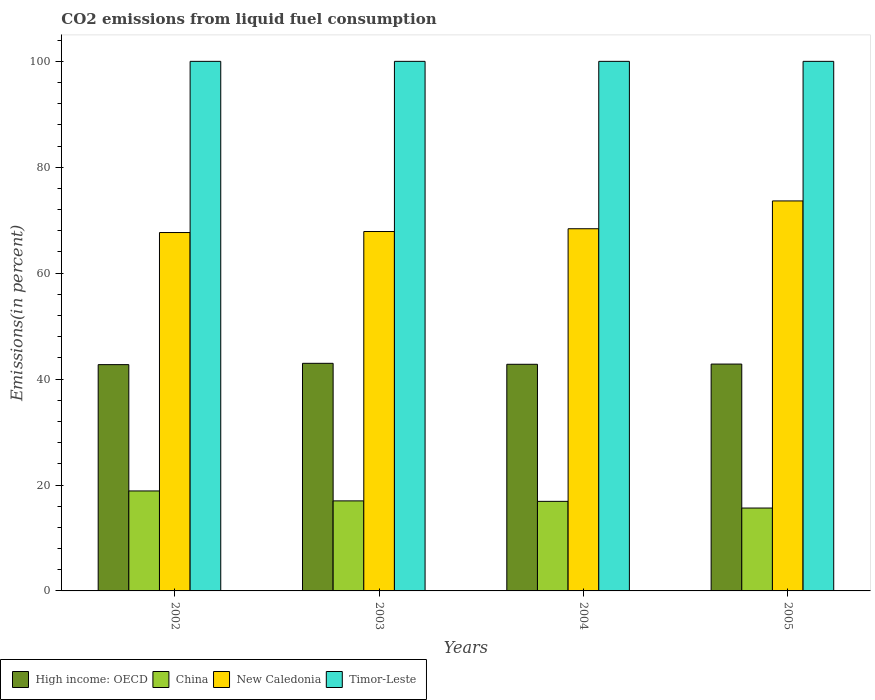How many different coloured bars are there?
Your response must be concise. 4. Are the number of bars on each tick of the X-axis equal?
Your answer should be compact. Yes. What is the label of the 1st group of bars from the left?
Ensure brevity in your answer.  2002. In how many cases, is the number of bars for a given year not equal to the number of legend labels?
Give a very brief answer. 0. What is the total CO2 emitted in New Caledonia in 2002?
Offer a terse response. 67.67. Across all years, what is the maximum total CO2 emitted in Timor-Leste?
Ensure brevity in your answer.  100. Across all years, what is the minimum total CO2 emitted in High income: OECD?
Your response must be concise. 42.73. In which year was the total CO2 emitted in New Caledonia maximum?
Offer a very short reply. 2005. In which year was the total CO2 emitted in China minimum?
Ensure brevity in your answer.  2005. What is the total total CO2 emitted in New Caledonia in the graph?
Offer a terse response. 277.57. What is the difference between the total CO2 emitted in New Caledonia in 2004 and that in 2005?
Your response must be concise. -5.25. What is the difference between the total CO2 emitted in China in 2003 and the total CO2 emitted in Timor-Leste in 2005?
Your response must be concise. -83. What is the average total CO2 emitted in China per year?
Your answer should be compact. 17.11. In the year 2002, what is the difference between the total CO2 emitted in High income: OECD and total CO2 emitted in New Caledonia?
Keep it short and to the point. -24.94. What is the ratio of the total CO2 emitted in China in 2002 to that in 2005?
Ensure brevity in your answer.  1.21. Is the total CO2 emitted in High income: OECD in 2004 less than that in 2005?
Provide a succinct answer. Yes. Is the difference between the total CO2 emitted in High income: OECD in 2002 and 2003 greater than the difference between the total CO2 emitted in New Caledonia in 2002 and 2003?
Your answer should be compact. No. What is the difference between the highest and the second highest total CO2 emitted in China?
Your answer should be very brief. 1.88. Is the sum of the total CO2 emitted in High income: OECD in 2002 and 2003 greater than the maximum total CO2 emitted in New Caledonia across all years?
Provide a succinct answer. Yes. Is it the case that in every year, the sum of the total CO2 emitted in New Caledonia and total CO2 emitted in High income: OECD is greater than the sum of total CO2 emitted in China and total CO2 emitted in Timor-Leste?
Your answer should be compact. No. What does the 1st bar from the left in 2002 represents?
Your response must be concise. High income: OECD. Are all the bars in the graph horizontal?
Offer a very short reply. No. What is the difference between two consecutive major ticks on the Y-axis?
Your answer should be very brief. 20. Are the values on the major ticks of Y-axis written in scientific E-notation?
Your response must be concise. No. Does the graph contain any zero values?
Your answer should be very brief. No. How many legend labels are there?
Offer a very short reply. 4. How are the legend labels stacked?
Offer a terse response. Horizontal. What is the title of the graph?
Your answer should be compact. CO2 emissions from liquid fuel consumption. Does "Iraq" appear as one of the legend labels in the graph?
Offer a very short reply. No. What is the label or title of the X-axis?
Your answer should be very brief. Years. What is the label or title of the Y-axis?
Give a very brief answer. Emissions(in percent). What is the Emissions(in percent) in High income: OECD in 2002?
Your response must be concise. 42.73. What is the Emissions(in percent) of China in 2002?
Provide a succinct answer. 18.88. What is the Emissions(in percent) in New Caledonia in 2002?
Offer a very short reply. 67.67. What is the Emissions(in percent) of High income: OECD in 2003?
Offer a terse response. 42.98. What is the Emissions(in percent) in China in 2003?
Make the answer very short. 17. What is the Emissions(in percent) in New Caledonia in 2003?
Ensure brevity in your answer.  67.87. What is the Emissions(in percent) in Timor-Leste in 2003?
Ensure brevity in your answer.  100. What is the Emissions(in percent) of High income: OECD in 2004?
Your answer should be very brief. 42.8. What is the Emissions(in percent) in China in 2004?
Offer a very short reply. 16.91. What is the Emissions(in percent) of New Caledonia in 2004?
Offer a terse response. 68.39. What is the Emissions(in percent) in High income: OECD in 2005?
Your answer should be compact. 42.84. What is the Emissions(in percent) in China in 2005?
Offer a terse response. 15.65. What is the Emissions(in percent) in New Caledonia in 2005?
Give a very brief answer. 73.64. What is the Emissions(in percent) in Timor-Leste in 2005?
Offer a very short reply. 100. Across all years, what is the maximum Emissions(in percent) in High income: OECD?
Your answer should be compact. 42.98. Across all years, what is the maximum Emissions(in percent) in China?
Your response must be concise. 18.88. Across all years, what is the maximum Emissions(in percent) of New Caledonia?
Make the answer very short. 73.64. Across all years, what is the maximum Emissions(in percent) of Timor-Leste?
Provide a short and direct response. 100. Across all years, what is the minimum Emissions(in percent) of High income: OECD?
Give a very brief answer. 42.73. Across all years, what is the minimum Emissions(in percent) of China?
Offer a very short reply. 15.65. Across all years, what is the minimum Emissions(in percent) in New Caledonia?
Your answer should be very brief. 67.67. What is the total Emissions(in percent) in High income: OECD in the graph?
Your answer should be compact. 171.34. What is the total Emissions(in percent) of China in the graph?
Offer a very short reply. 68.44. What is the total Emissions(in percent) in New Caledonia in the graph?
Provide a short and direct response. 277.57. What is the difference between the Emissions(in percent) of High income: OECD in 2002 and that in 2003?
Offer a terse response. -0.25. What is the difference between the Emissions(in percent) of China in 2002 and that in 2003?
Your answer should be compact. 1.88. What is the difference between the Emissions(in percent) in New Caledonia in 2002 and that in 2003?
Your response must be concise. -0.19. What is the difference between the Emissions(in percent) of High income: OECD in 2002 and that in 2004?
Offer a very short reply. -0.07. What is the difference between the Emissions(in percent) of China in 2002 and that in 2004?
Ensure brevity in your answer.  1.96. What is the difference between the Emissions(in percent) of New Caledonia in 2002 and that in 2004?
Offer a terse response. -0.72. What is the difference between the Emissions(in percent) of Timor-Leste in 2002 and that in 2004?
Your response must be concise. 0. What is the difference between the Emissions(in percent) in High income: OECD in 2002 and that in 2005?
Ensure brevity in your answer.  -0.11. What is the difference between the Emissions(in percent) in China in 2002 and that in 2005?
Ensure brevity in your answer.  3.23. What is the difference between the Emissions(in percent) of New Caledonia in 2002 and that in 2005?
Your answer should be very brief. -5.97. What is the difference between the Emissions(in percent) in High income: OECD in 2003 and that in 2004?
Offer a terse response. 0.18. What is the difference between the Emissions(in percent) in China in 2003 and that in 2004?
Provide a succinct answer. 0.09. What is the difference between the Emissions(in percent) in New Caledonia in 2003 and that in 2004?
Give a very brief answer. -0.52. What is the difference between the Emissions(in percent) of Timor-Leste in 2003 and that in 2004?
Provide a short and direct response. 0. What is the difference between the Emissions(in percent) in High income: OECD in 2003 and that in 2005?
Ensure brevity in your answer.  0.14. What is the difference between the Emissions(in percent) of China in 2003 and that in 2005?
Your answer should be compact. 1.35. What is the difference between the Emissions(in percent) in New Caledonia in 2003 and that in 2005?
Give a very brief answer. -5.78. What is the difference between the Emissions(in percent) in Timor-Leste in 2003 and that in 2005?
Provide a short and direct response. 0. What is the difference between the Emissions(in percent) in High income: OECD in 2004 and that in 2005?
Offer a very short reply. -0.04. What is the difference between the Emissions(in percent) in China in 2004 and that in 2005?
Provide a short and direct response. 1.26. What is the difference between the Emissions(in percent) of New Caledonia in 2004 and that in 2005?
Provide a short and direct response. -5.25. What is the difference between the Emissions(in percent) of Timor-Leste in 2004 and that in 2005?
Give a very brief answer. 0. What is the difference between the Emissions(in percent) of High income: OECD in 2002 and the Emissions(in percent) of China in 2003?
Give a very brief answer. 25.73. What is the difference between the Emissions(in percent) of High income: OECD in 2002 and the Emissions(in percent) of New Caledonia in 2003?
Keep it short and to the point. -25.14. What is the difference between the Emissions(in percent) of High income: OECD in 2002 and the Emissions(in percent) of Timor-Leste in 2003?
Your answer should be compact. -57.27. What is the difference between the Emissions(in percent) of China in 2002 and the Emissions(in percent) of New Caledonia in 2003?
Keep it short and to the point. -48.99. What is the difference between the Emissions(in percent) of China in 2002 and the Emissions(in percent) of Timor-Leste in 2003?
Give a very brief answer. -81.12. What is the difference between the Emissions(in percent) in New Caledonia in 2002 and the Emissions(in percent) in Timor-Leste in 2003?
Ensure brevity in your answer.  -32.33. What is the difference between the Emissions(in percent) of High income: OECD in 2002 and the Emissions(in percent) of China in 2004?
Your answer should be compact. 25.82. What is the difference between the Emissions(in percent) of High income: OECD in 2002 and the Emissions(in percent) of New Caledonia in 2004?
Offer a very short reply. -25.66. What is the difference between the Emissions(in percent) of High income: OECD in 2002 and the Emissions(in percent) of Timor-Leste in 2004?
Your answer should be very brief. -57.27. What is the difference between the Emissions(in percent) of China in 2002 and the Emissions(in percent) of New Caledonia in 2004?
Your answer should be very brief. -49.51. What is the difference between the Emissions(in percent) in China in 2002 and the Emissions(in percent) in Timor-Leste in 2004?
Make the answer very short. -81.12. What is the difference between the Emissions(in percent) in New Caledonia in 2002 and the Emissions(in percent) in Timor-Leste in 2004?
Ensure brevity in your answer.  -32.33. What is the difference between the Emissions(in percent) in High income: OECD in 2002 and the Emissions(in percent) in China in 2005?
Your answer should be compact. 27.08. What is the difference between the Emissions(in percent) in High income: OECD in 2002 and the Emissions(in percent) in New Caledonia in 2005?
Your response must be concise. -30.91. What is the difference between the Emissions(in percent) of High income: OECD in 2002 and the Emissions(in percent) of Timor-Leste in 2005?
Your answer should be compact. -57.27. What is the difference between the Emissions(in percent) of China in 2002 and the Emissions(in percent) of New Caledonia in 2005?
Provide a short and direct response. -54.77. What is the difference between the Emissions(in percent) in China in 2002 and the Emissions(in percent) in Timor-Leste in 2005?
Your answer should be compact. -81.12. What is the difference between the Emissions(in percent) in New Caledonia in 2002 and the Emissions(in percent) in Timor-Leste in 2005?
Make the answer very short. -32.33. What is the difference between the Emissions(in percent) of High income: OECD in 2003 and the Emissions(in percent) of China in 2004?
Make the answer very short. 26.07. What is the difference between the Emissions(in percent) in High income: OECD in 2003 and the Emissions(in percent) in New Caledonia in 2004?
Offer a very short reply. -25.41. What is the difference between the Emissions(in percent) in High income: OECD in 2003 and the Emissions(in percent) in Timor-Leste in 2004?
Your answer should be compact. -57.02. What is the difference between the Emissions(in percent) of China in 2003 and the Emissions(in percent) of New Caledonia in 2004?
Offer a terse response. -51.39. What is the difference between the Emissions(in percent) of China in 2003 and the Emissions(in percent) of Timor-Leste in 2004?
Make the answer very short. -83. What is the difference between the Emissions(in percent) of New Caledonia in 2003 and the Emissions(in percent) of Timor-Leste in 2004?
Provide a succinct answer. -32.13. What is the difference between the Emissions(in percent) in High income: OECD in 2003 and the Emissions(in percent) in China in 2005?
Your answer should be very brief. 27.33. What is the difference between the Emissions(in percent) in High income: OECD in 2003 and the Emissions(in percent) in New Caledonia in 2005?
Your answer should be compact. -30.66. What is the difference between the Emissions(in percent) of High income: OECD in 2003 and the Emissions(in percent) of Timor-Leste in 2005?
Provide a short and direct response. -57.02. What is the difference between the Emissions(in percent) in China in 2003 and the Emissions(in percent) in New Caledonia in 2005?
Give a very brief answer. -56.64. What is the difference between the Emissions(in percent) in China in 2003 and the Emissions(in percent) in Timor-Leste in 2005?
Your answer should be very brief. -83. What is the difference between the Emissions(in percent) of New Caledonia in 2003 and the Emissions(in percent) of Timor-Leste in 2005?
Give a very brief answer. -32.13. What is the difference between the Emissions(in percent) of High income: OECD in 2004 and the Emissions(in percent) of China in 2005?
Make the answer very short. 27.15. What is the difference between the Emissions(in percent) in High income: OECD in 2004 and the Emissions(in percent) in New Caledonia in 2005?
Your response must be concise. -30.85. What is the difference between the Emissions(in percent) in High income: OECD in 2004 and the Emissions(in percent) in Timor-Leste in 2005?
Ensure brevity in your answer.  -57.2. What is the difference between the Emissions(in percent) in China in 2004 and the Emissions(in percent) in New Caledonia in 2005?
Make the answer very short. -56.73. What is the difference between the Emissions(in percent) of China in 2004 and the Emissions(in percent) of Timor-Leste in 2005?
Keep it short and to the point. -83.09. What is the difference between the Emissions(in percent) of New Caledonia in 2004 and the Emissions(in percent) of Timor-Leste in 2005?
Provide a succinct answer. -31.61. What is the average Emissions(in percent) in High income: OECD per year?
Provide a succinct answer. 42.84. What is the average Emissions(in percent) in China per year?
Offer a very short reply. 17.11. What is the average Emissions(in percent) in New Caledonia per year?
Keep it short and to the point. 69.39. What is the average Emissions(in percent) of Timor-Leste per year?
Ensure brevity in your answer.  100. In the year 2002, what is the difference between the Emissions(in percent) of High income: OECD and Emissions(in percent) of China?
Your response must be concise. 23.85. In the year 2002, what is the difference between the Emissions(in percent) of High income: OECD and Emissions(in percent) of New Caledonia?
Provide a succinct answer. -24.94. In the year 2002, what is the difference between the Emissions(in percent) of High income: OECD and Emissions(in percent) of Timor-Leste?
Ensure brevity in your answer.  -57.27. In the year 2002, what is the difference between the Emissions(in percent) in China and Emissions(in percent) in New Caledonia?
Your answer should be very brief. -48.8. In the year 2002, what is the difference between the Emissions(in percent) in China and Emissions(in percent) in Timor-Leste?
Keep it short and to the point. -81.12. In the year 2002, what is the difference between the Emissions(in percent) of New Caledonia and Emissions(in percent) of Timor-Leste?
Your answer should be compact. -32.33. In the year 2003, what is the difference between the Emissions(in percent) in High income: OECD and Emissions(in percent) in China?
Offer a terse response. 25.98. In the year 2003, what is the difference between the Emissions(in percent) in High income: OECD and Emissions(in percent) in New Caledonia?
Your answer should be compact. -24.89. In the year 2003, what is the difference between the Emissions(in percent) in High income: OECD and Emissions(in percent) in Timor-Leste?
Offer a very short reply. -57.02. In the year 2003, what is the difference between the Emissions(in percent) of China and Emissions(in percent) of New Caledonia?
Make the answer very short. -50.87. In the year 2003, what is the difference between the Emissions(in percent) in China and Emissions(in percent) in Timor-Leste?
Ensure brevity in your answer.  -83. In the year 2003, what is the difference between the Emissions(in percent) of New Caledonia and Emissions(in percent) of Timor-Leste?
Provide a short and direct response. -32.13. In the year 2004, what is the difference between the Emissions(in percent) of High income: OECD and Emissions(in percent) of China?
Offer a terse response. 25.88. In the year 2004, what is the difference between the Emissions(in percent) in High income: OECD and Emissions(in percent) in New Caledonia?
Offer a very short reply. -25.59. In the year 2004, what is the difference between the Emissions(in percent) of High income: OECD and Emissions(in percent) of Timor-Leste?
Keep it short and to the point. -57.2. In the year 2004, what is the difference between the Emissions(in percent) of China and Emissions(in percent) of New Caledonia?
Your answer should be compact. -51.48. In the year 2004, what is the difference between the Emissions(in percent) of China and Emissions(in percent) of Timor-Leste?
Your answer should be compact. -83.09. In the year 2004, what is the difference between the Emissions(in percent) of New Caledonia and Emissions(in percent) of Timor-Leste?
Keep it short and to the point. -31.61. In the year 2005, what is the difference between the Emissions(in percent) in High income: OECD and Emissions(in percent) in China?
Provide a succinct answer. 27.18. In the year 2005, what is the difference between the Emissions(in percent) in High income: OECD and Emissions(in percent) in New Caledonia?
Make the answer very short. -30.81. In the year 2005, what is the difference between the Emissions(in percent) of High income: OECD and Emissions(in percent) of Timor-Leste?
Your answer should be very brief. -57.16. In the year 2005, what is the difference between the Emissions(in percent) in China and Emissions(in percent) in New Caledonia?
Your answer should be compact. -57.99. In the year 2005, what is the difference between the Emissions(in percent) of China and Emissions(in percent) of Timor-Leste?
Your answer should be compact. -84.35. In the year 2005, what is the difference between the Emissions(in percent) of New Caledonia and Emissions(in percent) of Timor-Leste?
Give a very brief answer. -26.36. What is the ratio of the Emissions(in percent) of High income: OECD in 2002 to that in 2003?
Give a very brief answer. 0.99. What is the ratio of the Emissions(in percent) in China in 2002 to that in 2003?
Provide a succinct answer. 1.11. What is the ratio of the Emissions(in percent) in High income: OECD in 2002 to that in 2004?
Make the answer very short. 1. What is the ratio of the Emissions(in percent) in China in 2002 to that in 2004?
Offer a very short reply. 1.12. What is the ratio of the Emissions(in percent) in Timor-Leste in 2002 to that in 2004?
Give a very brief answer. 1. What is the ratio of the Emissions(in percent) of High income: OECD in 2002 to that in 2005?
Keep it short and to the point. 1. What is the ratio of the Emissions(in percent) in China in 2002 to that in 2005?
Your response must be concise. 1.21. What is the ratio of the Emissions(in percent) of New Caledonia in 2002 to that in 2005?
Offer a terse response. 0.92. What is the ratio of the Emissions(in percent) in Timor-Leste in 2002 to that in 2005?
Provide a succinct answer. 1. What is the ratio of the Emissions(in percent) of Timor-Leste in 2003 to that in 2004?
Provide a short and direct response. 1. What is the ratio of the Emissions(in percent) of China in 2003 to that in 2005?
Offer a very short reply. 1.09. What is the ratio of the Emissions(in percent) in New Caledonia in 2003 to that in 2005?
Offer a terse response. 0.92. What is the ratio of the Emissions(in percent) of China in 2004 to that in 2005?
Provide a succinct answer. 1.08. What is the ratio of the Emissions(in percent) of New Caledonia in 2004 to that in 2005?
Provide a succinct answer. 0.93. What is the ratio of the Emissions(in percent) of Timor-Leste in 2004 to that in 2005?
Your answer should be very brief. 1. What is the difference between the highest and the second highest Emissions(in percent) in High income: OECD?
Offer a very short reply. 0.14. What is the difference between the highest and the second highest Emissions(in percent) of China?
Make the answer very short. 1.88. What is the difference between the highest and the second highest Emissions(in percent) of New Caledonia?
Ensure brevity in your answer.  5.25. What is the difference between the highest and the lowest Emissions(in percent) of High income: OECD?
Your answer should be very brief. 0.25. What is the difference between the highest and the lowest Emissions(in percent) in China?
Provide a short and direct response. 3.23. What is the difference between the highest and the lowest Emissions(in percent) of New Caledonia?
Make the answer very short. 5.97. 